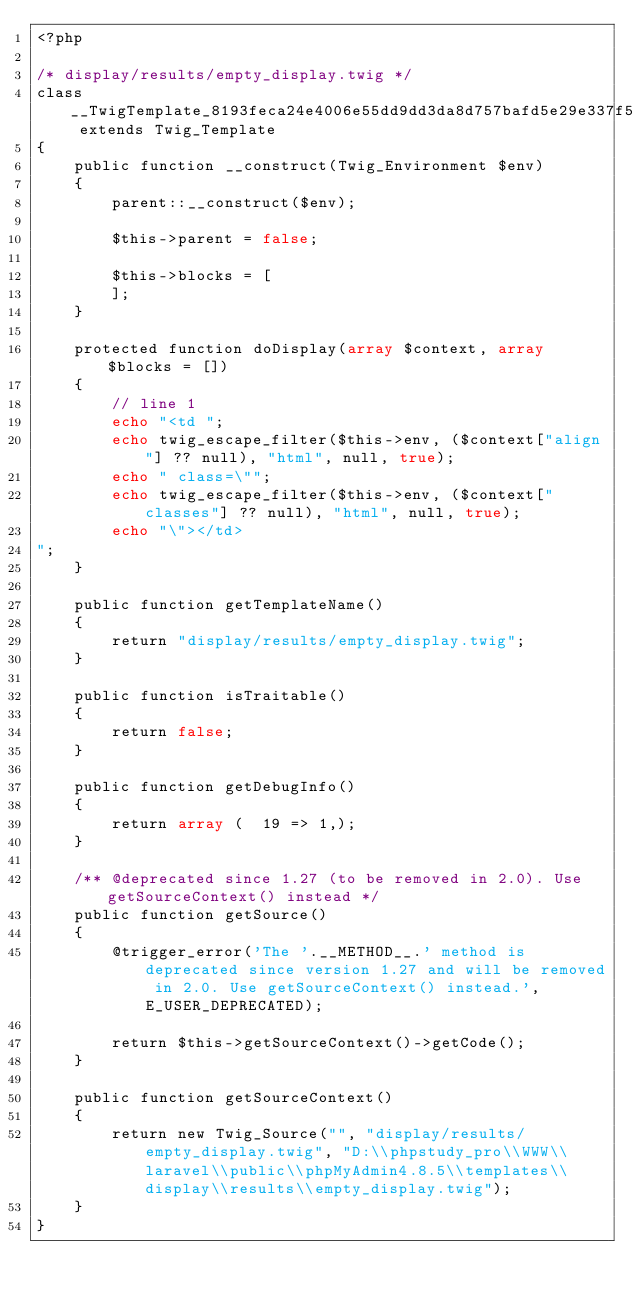<code> <loc_0><loc_0><loc_500><loc_500><_PHP_><?php

/* display/results/empty_display.twig */
class __TwigTemplate_8193feca24e4006e55dd9dd3da8d757bafd5e29e337f545534264954de9d210b extends Twig_Template
{
    public function __construct(Twig_Environment $env)
    {
        parent::__construct($env);

        $this->parent = false;

        $this->blocks = [
        ];
    }

    protected function doDisplay(array $context, array $blocks = [])
    {
        // line 1
        echo "<td ";
        echo twig_escape_filter($this->env, ($context["align"] ?? null), "html", null, true);
        echo " class=\"";
        echo twig_escape_filter($this->env, ($context["classes"] ?? null), "html", null, true);
        echo "\"></td>
";
    }

    public function getTemplateName()
    {
        return "display/results/empty_display.twig";
    }

    public function isTraitable()
    {
        return false;
    }

    public function getDebugInfo()
    {
        return array (  19 => 1,);
    }

    /** @deprecated since 1.27 (to be removed in 2.0). Use getSourceContext() instead */
    public function getSource()
    {
        @trigger_error('The '.__METHOD__.' method is deprecated since version 1.27 and will be removed in 2.0. Use getSourceContext() instead.', E_USER_DEPRECATED);

        return $this->getSourceContext()->getCode();
    }

    public function getSourceContext()
    {
        return new Twig_Source("", "display/results/empty_display.twig", "D:\\phpstudy_pro\\WWW\\laravel\\public\\phpMyAdmin4.8.5\\templates\\display\\results\\empty_display.twig");
    }
}
</code> 